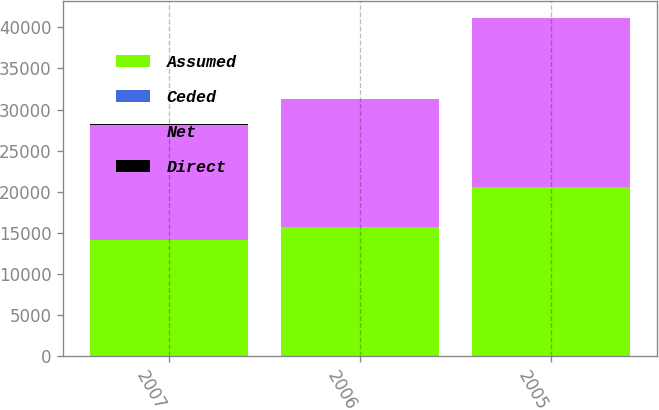Convert chart to OTSL. <chart><loc_0><loc_0><loc_500><loc_500><stacked_bar_chart><ecel><fcel>2007<fcel>2006<fcel>2005<nl><fcel>Assumed<fcel>14089<fcel>15652<fcel>20548<nl><fcel>Ceded<fcel>1<fcel>1<fcel>1<nl><fcel>Net<fcel>14071<fcel>15633<fcel>20528<nl><fcel>Direct<fcel>19<fcel>20<fcel>21<nl></chart> 